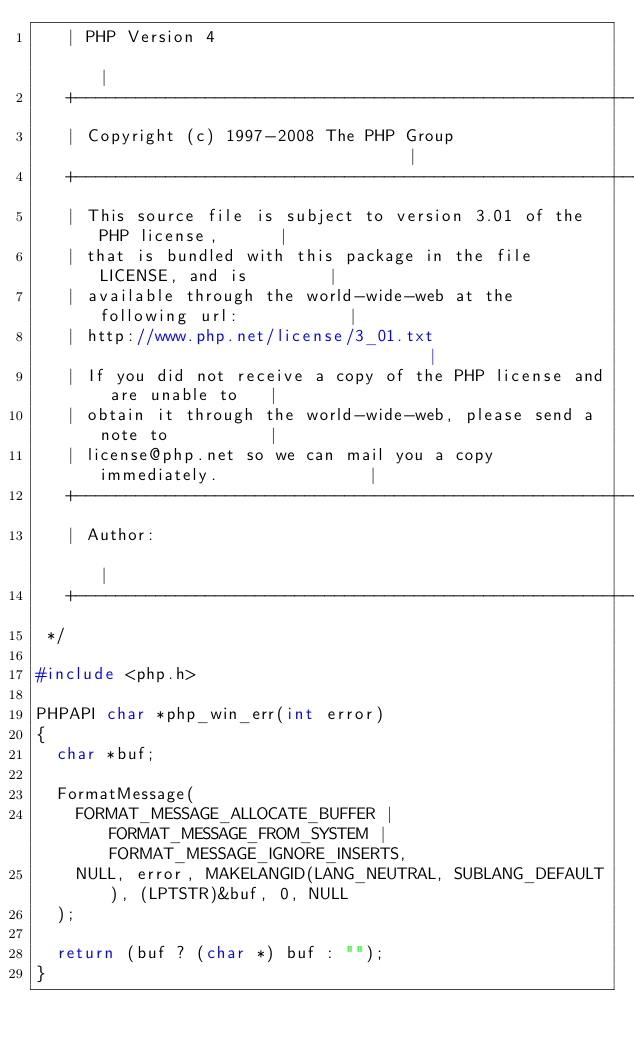Convert code to text. <code><loc_0><loc_0><loc_500><loc_500><_C_>   | PHP Version 4                                                        |
   +----------------------------------------------------------------------+
   | Copyright (c) 1997-2008 The PHP Group                                |
   +----------------------------------------------------------------------+
   | This source file is subject to version 3.01 of the PHP license,      |
   | that is bundled with this package in the file LICENSE, and is        |
   | available through the world-wide-web at the following url:           |
   | http://www.php.net/license/3_01.txt                                  |
   | If you did not receive a copy of the PHP license and are unable to   |
   | obtain it through the world-wide-web, please send a note to          |
   | license@php.net so we can mail you a copy immediately.               |
   +----------------------------------------------------------------------+
   | Author:                                                              |
   +----------------------------------------------------------------------+
 */

#include <php.h>

PHPAPI char *php_win_err(int error)
{
	char *buf;

	FormatMessage(
		FORMAT_MESSAGE_ALLOCATE_BUFFER | FORMAT_MESSAGE_FROM_SYSTEM |	FORMAT_MESSAGE_IGNORE_INSERTS,
		NULL, error, MAKELANGID(LANG_NEUTRAL, SUBLANG_DEFAULT),	(LPTSTR)&buf, 0, NULL
	);

	return (buf ? (char *) buf : "");
}
</code> 